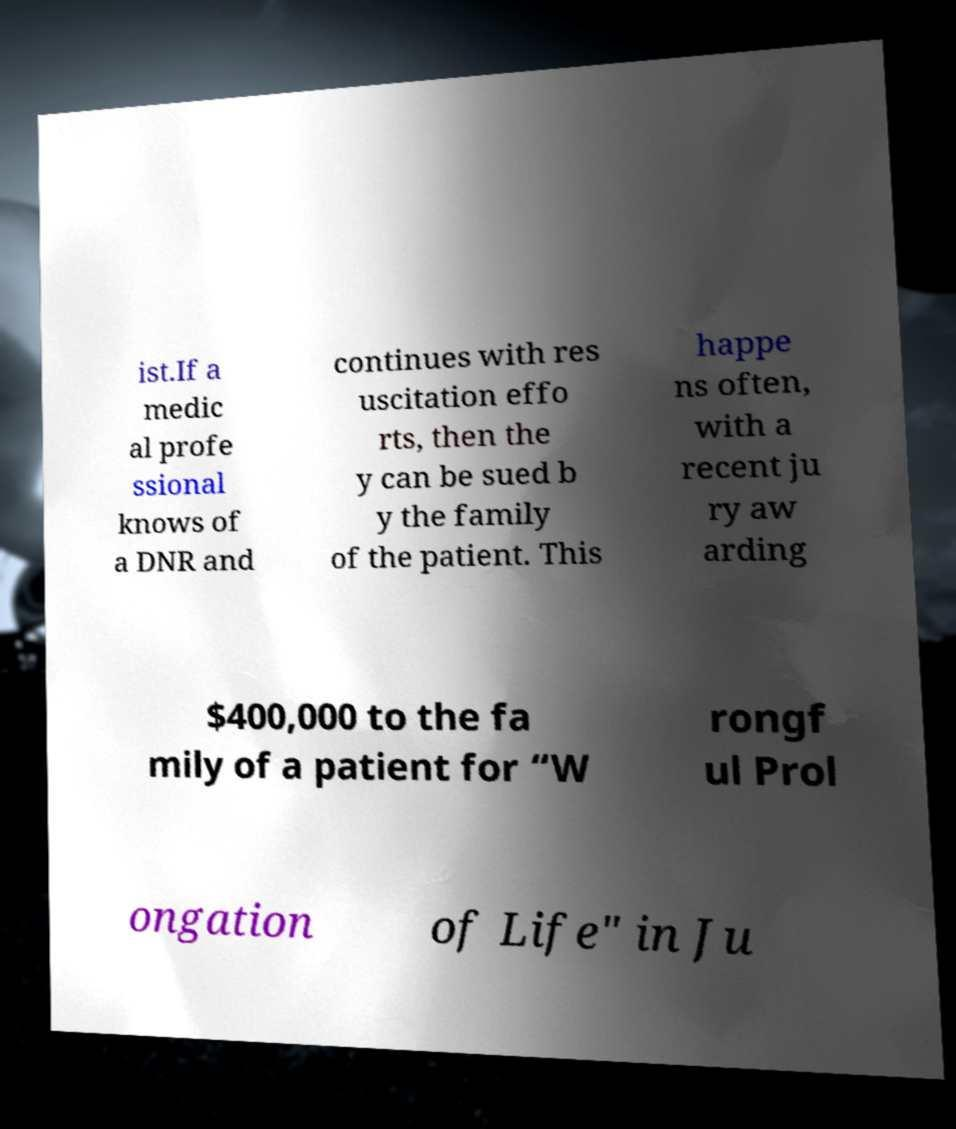I need the written content from this picture converted into text. Can you do that? ist.If a medic al profe ssional knows of a DNR and continues with res uscitation effo rts, then the y can be sued b y the family of the patient. This happe ns often, with a recent ju ry aw arding $400,000 to the fa mily of a patient for “W rongf ul Prol ongation of Life" in Ju 